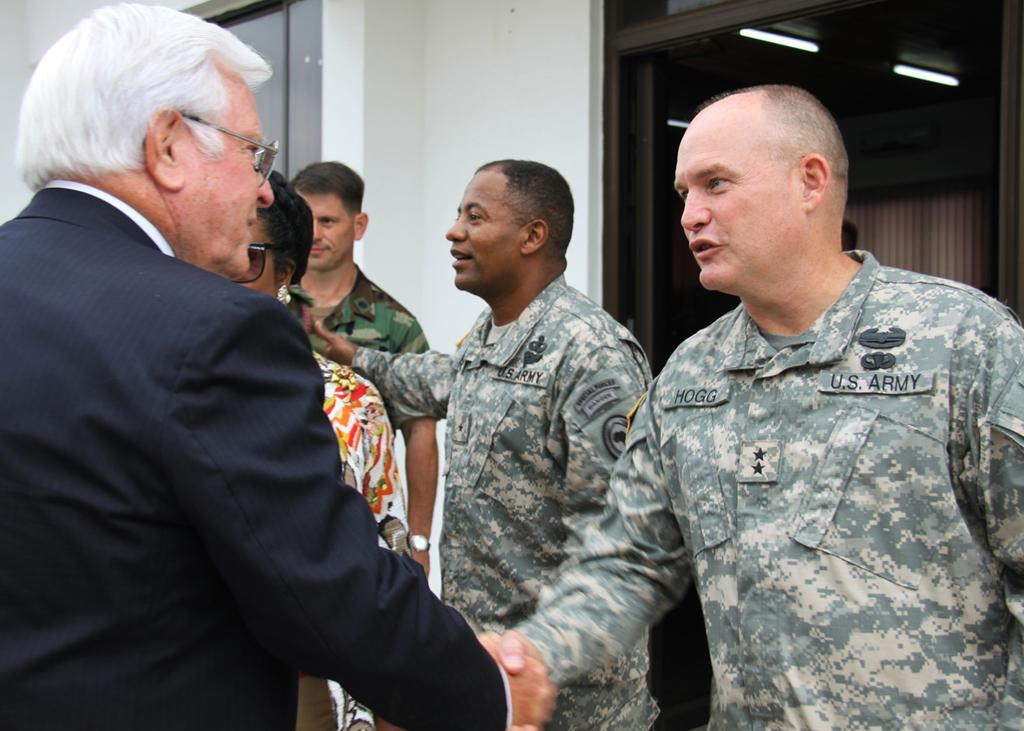How many people are present in the image? There are five people in the image. What are two of the people doing in the image? Two men are shaking hands in the image. What can be seen in the background of the image? There is a window, a wall, lights, and curtains in the background. What is the name of the actor who plays the lead role in the image? There is no actor or lead role in the image, as it is a photograph of people shaking hands. Does the existence of the image prove the existence of a parallel universe? The existence of the image does not prove the existence of a parallel universe, as it is simply a photograph of people shaking hands. 